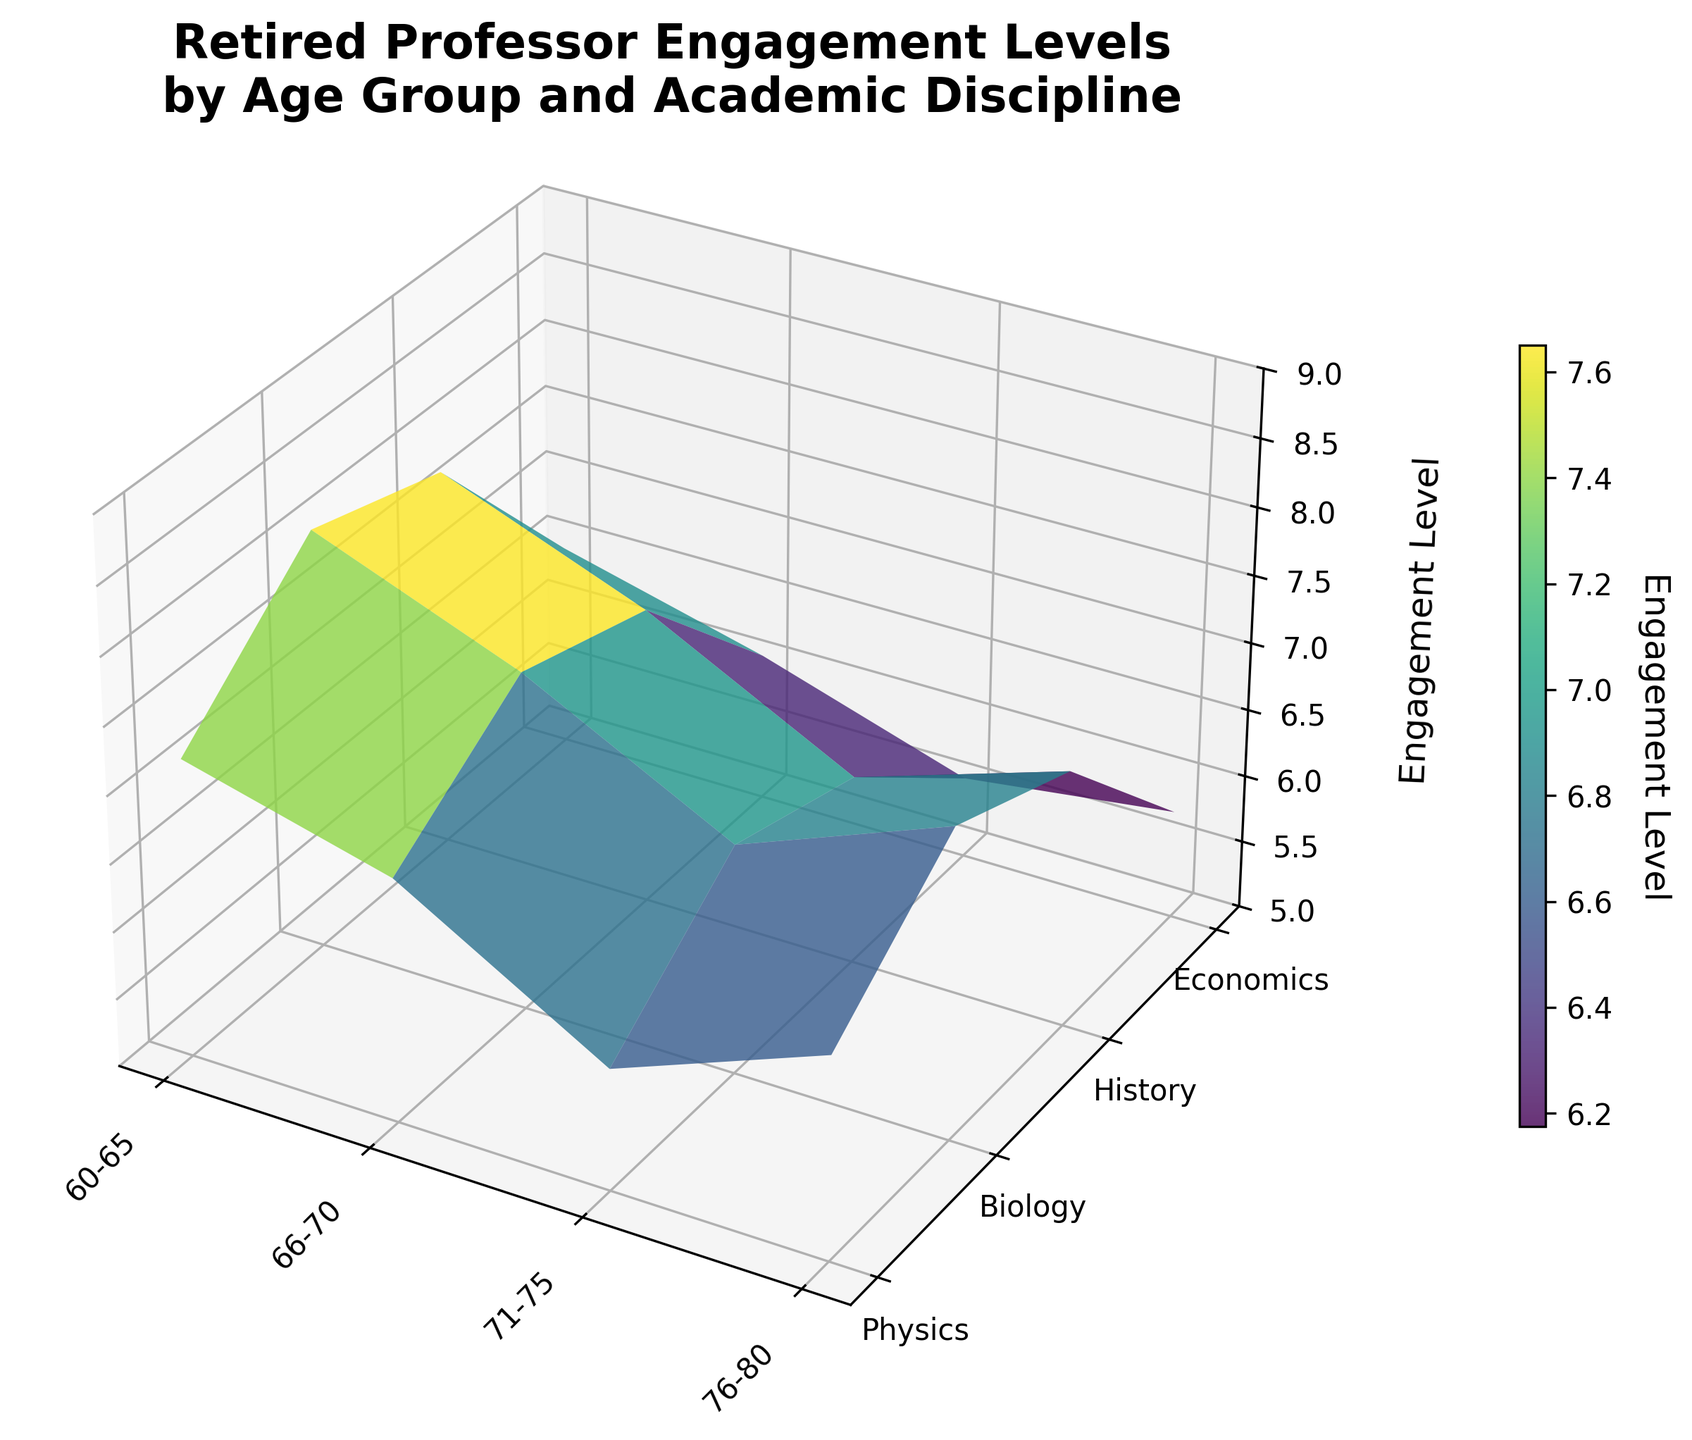What is the title of the figure? The title is typically located at the top of the figure. In this case, it is "Retired Professor Engagement Levels by Age Group and Academic Discipline".
Answer: Retired Professor Engagement Levels by Age Group and Academic Discipline What age group has the highest engagement level in Physics? Identify the age group and compare their engagement levels within the Physics discipline. The highest value will determine the answer. The value 8.1 appears for the 66-70 age group in Physics.
Answer: 66-70 Which academic discipline has the lowest engagement level for the 76-80 age group? Look at the engagement levels for the 76-80 age group across all disciplines. The discipline with the smallest engagement level is History with a value of 5.6.
Answer: History What is the range of engagement levels for Economics across all age groups? Identify the minimum and maximum engagement levels for Economics across all age groups. The minimum is 5.8 (76-80) and the maximum is 7.3 (66-70). The range is 7.3 - 5.8 = 1.5.
Answer: 1.5 Which age group shows the most consistent engagement levels across all disciplines? Evaluate the variability of engagement levels within each age group. The 66-70 age group has the most consistent engagement levels: Physics (8.1), Biology (7.5), History (6.7), Economics (7.3), showing less spread compared to other age groups.
Answer: 66-70 What is the mean engagement level for the Biology discipline? Sum the engagement levels for Biology across all age groups and divide by the number of age groups: (6.8 + 7.5 + 7.2 + 6.1)/4 = 6.9.
Answer: 6.9 How does the engagement level in History for the 71-75 age group compare to Physics for the 60-65 age group? Compare the values directly: History (71-75) has an engagement level of 6.4 and Physics (60-65) has an engagement level of 7.2. So, Physics (60-65) is higher.
Answer: Physics (60-65) is higher What trend do you observe in engagement levels for the Physics discipline as the age group increases? Observe the engagement level values for Physics across increasing age groups: 7.2 (60-65), 8.1 (66-70), 7.8 (71-75), 6.5 (76-80). Engagement levels peak at 66-70 and then decrease.
Answer: Peaks at 66-70 then decreases What is the engagement level difference between the Biology and History disciplines for the 66-70 age group? Subtract the engagement level for History from Biology for the 66-70 age group: 7.5 (Biology) - 6.7 (History) = 0.8.
Answer: 0.8 Which academic discipline shows the most significant decline in engagement levels from the 66-70 age group to the 76-80 age group? Look at the values and calculate the difference for each discipline between these two age groups. Physics has the most significant decline: 8.1 (66-70) to 6.5 (76-80), a difference of 1.6.
Answer: Physics 